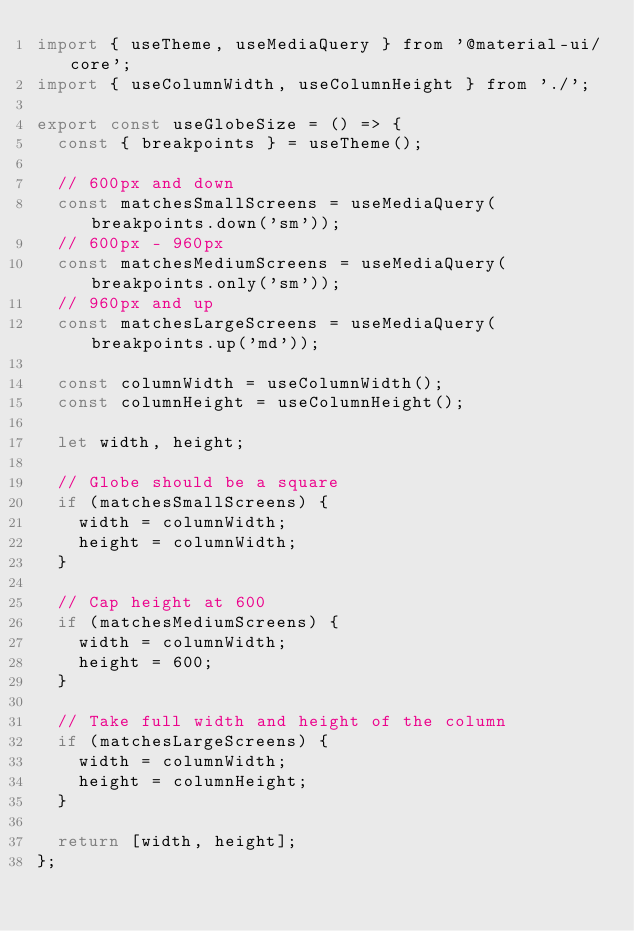<code> <loc_0><loc_0><loc_500><loc_500><_JavaScript_>import { useTheme, useMediaQuery } from '@material-ui/core';
import { useColumnWidth, useColumnHeight } from './';

export const useGlobeSize = () => {
  const { breakpoints } = useTheme();

  // 600px and down
  const matchesSmallScreens = useMediaQuery(breakpoints.down('sm'));
  // 600px - 960px
  const matchesMediumScreens = useMediaQuery(breakpoints.only('sm'));
  // 960px and up
  const matchesLargeScreens = useMediaQuery(breakpoints.up('md'));

  const columnWidth = useColumnWidth();
  const columnHeight = useColumnHeight();

  let width, height;

  // Globe should be a square
  if (matchesSmallScreens) {
    width = columnWidth;
    height = columnWidth;
  }

  // Cap height at 600
  if (matchesMediumScreens) {
    width = columnWidth;
    height = 600;
  }

  // Take full width and height of the column
  if (matchesLargeScreens) {
    width = columnWidth;
    height = columnHeight;
  }

  return [width, height];
};
</code> 